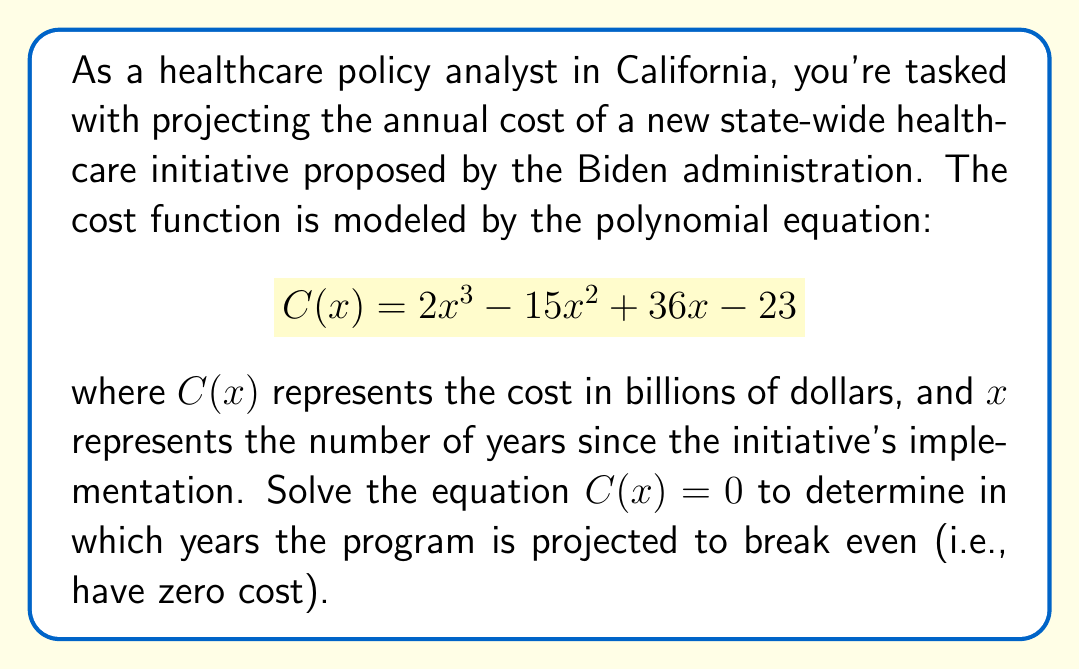Help me with this question. To solve this polynomial equation, we'll follow these steps:

1) First, we need to factor the polynomial $C(x) = 2x^3 - 15x^2 + 36x - 23$

2) We can see that all terms are divisible by 1, so there's no common factor to extract.

3) Let's try to guess one factor. Through trial and error or by using the rational root theorem, we can find that $(x - 1)$ is a factor.

4) Dividing $2x^3 - 15x^2 + 36x - 23$ by $(x - 1)$, we get:

   $2x^3 - 15x^2 + 36x - 23 = (x - 1)(2x^2 - 13x + 23)$

5) Now we need to factor the quadratic $2x^2 - 13x + 23$

6) The quadratic formula $\frac{-b \pm \sqrt{b^2 - 4ac}}{2a}$ gives us:

   $x = \frac{13 \pm \sqrt{169 - 184}}{4} = \frac{13 \pm \sqrt{-15}}{4}$

7) Since this results in complex roots, $2x^2 - 13x + 23$ cannot be factored further over the real numbers.

8) Therefore, the fully factored form of the polynomial is:

   $C(x) = (x - 1)(2x^2 - 13x + 23)$

9) Setting $C(x) = 0$, we get:

   $(x - 1)(2x^2 - 13x + 23) = 0$

10) By the zero product property, either $x - 1 = 0$ or $2x^2 - 13x + 23 = 0$

11) From $x - 1 = 0$, we get $x = 1$

12) The quadratic $2x^2 - 13x + 23 = 0$ has no real solutions as we found earlier.

Therefore, the only real solution is $x = 1$.
Answer: The program is projected to break even (have zero cost) after 1 year of implementation. 